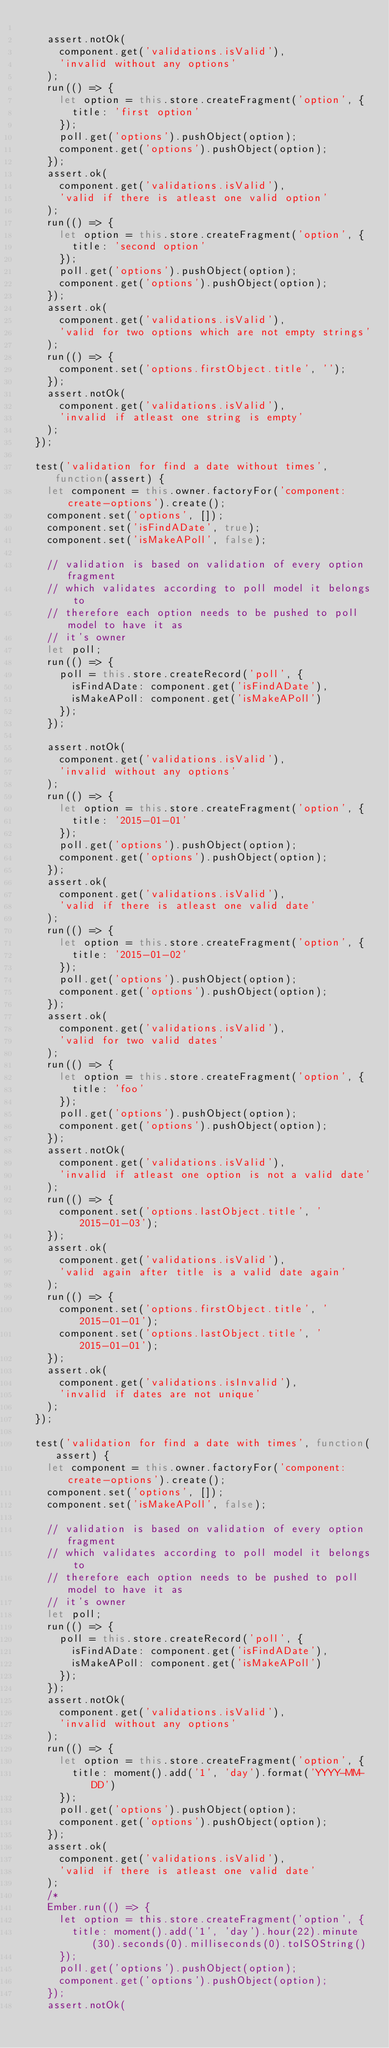Convert code to text. <code><loc_0><loc_0><loc_500><loc_500><_JavaScript_>
    assert.notOk(
      component.get('validations.isValid'),
      'invalid without any options'
    );
    run(() => {
      let option = this.store.createFragment('option', {
        title: 'first option'
      });
      poll.get('options').pushObject(option);
      component.get('options').pushObject(option);
    });
    assert.ok(
      component.get('validations.isValid'),
      'valid if there is atleast one valid option'
    );
    run(() => {
      let option = this.store.createFragment('option', {
        title: 'second option'
      });
      poll.get('options').pushObject(option);
      component.get('options').pushObject(option);
    });
    assert.ok(
      component.get('validations.isValid'),
      'valid for two options which are not empty strings'
    );
    run(() => {
      component.set('options.firstObject.title', '');
    });
    assert.notOk(
      component.get('validations.isValid'),
      'invalid if atleast one string is empty'
    );
  });

  test('validation for find a date without times', function(assert) {
    let component = this.owner.factoryFor('component:create-options').create();
    component.set('options', []);
    component.set('isFindADate', true);
    component.set('isMakeAPoll', false);

    // validation is based on validation of every option fragment
    // which validates according to poll model it belongs to
    // therefore each option needs to be pushed to poll model to have it as
    // it's owner
    let poll;
    run(() => {
      poll = this.store.createRecord('poll', {
        isFindADate: component.get('isFindADate'),
        isMakeAPoll: component.get('isMakeAPoll')
      });
    });

    assert.notOk(
      component.get('validations.isValid'),
      'invalid without any options'
    );
    run(() => {
      let option = this.store.createFragment('option', {
        title: '2015-01-01'
      });
      poll.get('options').pushObject(option);
      component.get('options').pushObject(option);
    });
    assert.ok(
      component.get('validations.isValid'),
      'valid if there is atleast one valid date'
    );
    run(() => {
      let option = this.store.createFragment('option', {
        title: '2015-01-02'
      });
      poll.get('options').pushObject(option);
      component.get('options').pushObject(option);
    });
    assert.ok(
      component.get('validations.isValid'),
      'valid for two valid dates'
    );
    run(() => {
      let option = this.store.createFragment('option', {
        title: 'foo'
      });
      poll.get('options').pushObject(option);
      component.get('options').pushObject(option);
    });
    assert.notOk(
      component.get('validations.isValid'),
      'invalid if atleast one option is not a valid date'
    );
    run(() => {
      component.set('options.lastObject.title', '2015-01-03');
    });
    assert.ok(
      component.get('validations.isValid'),
      'valid again after title is a valid date again'
    );
    run(() => {
      component.set('options.firstObject.title', '2015-01-01');
      component.set('options.lastObject.title', '2015-01-01');
    });
    assert.ok(
      component.get('validations.isInvalid'),
      'invalid if dates are not unique'
    );
  });

  test('validation for find a date with times', function(assert) {
    let component = this.owner.factoryFor('component:create-options').create();
    component.set('options', []);
    component.set('isMakeAPoll', false);

    // validation is based on validation of every option fragment
    // which validates according to poll model it belongs to
    // therefore each option needs to be pushed to poll model to have it as
    // it's owner
    let poll;
    run(() => {
      poll = this.store.createRecord('poll', {
        isFindADate: component.get('isFindADate'),
        isMakeAPoll: component.get('isMakeAPoll')
      });
    });
    assert.notOk(
      component.get('validations.isValid'),
      'invalid without any options'
    );
    run(() => {
      let option = this.store.createFragment('option', {
        title: moment().add('1', 'day').format('YYYY-MM-DD')
      });
      poll.get('options').pushObject(option);
      component.get('options').pushObject(option);
    });
    assert.ok(
      component.get('validations.isValid'),
      'valid if there is atleast one valid date'
    );
    /*
    Ember.run(() => {
      let option = this.store.createFragment('option', {
        title: moment().add('1', 'day').hour(22).minute(30).seconds(0).milliseconds(0).toISOString()
      });
      poll.get('options').pushObject(option);
      component.get('options').pushObject(option);
    });
    assert.notOk(</code> 